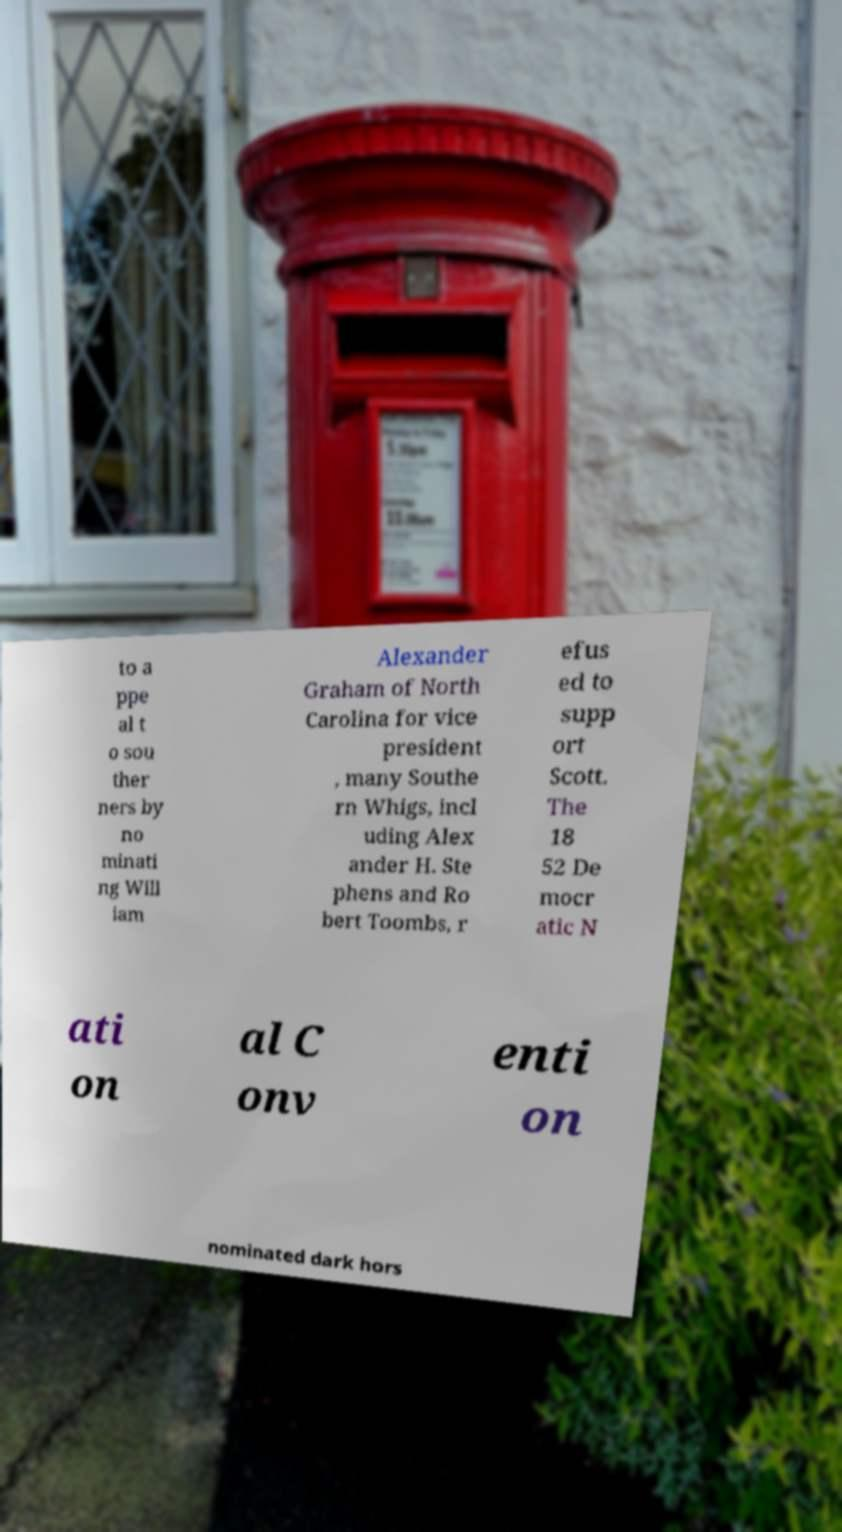Could you assist in decoding the text presented in this image and type it out clearly? to a ppe al t o sou ther ners by no minati ng Will iam Alexander Graham of North Carolina for vice president , many Southe rn Whigs, incl uding Alex ander H. Ste phens and Ro bert Toombs, r efus ed to supp ort Scott. The 18 52 De mocr atic N ati on al C onv enti on nominated dark hors 